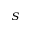Convert formula to latex. <formula><loc_0><loc_0><loc_500><loc_500>_ { S }</formula> 